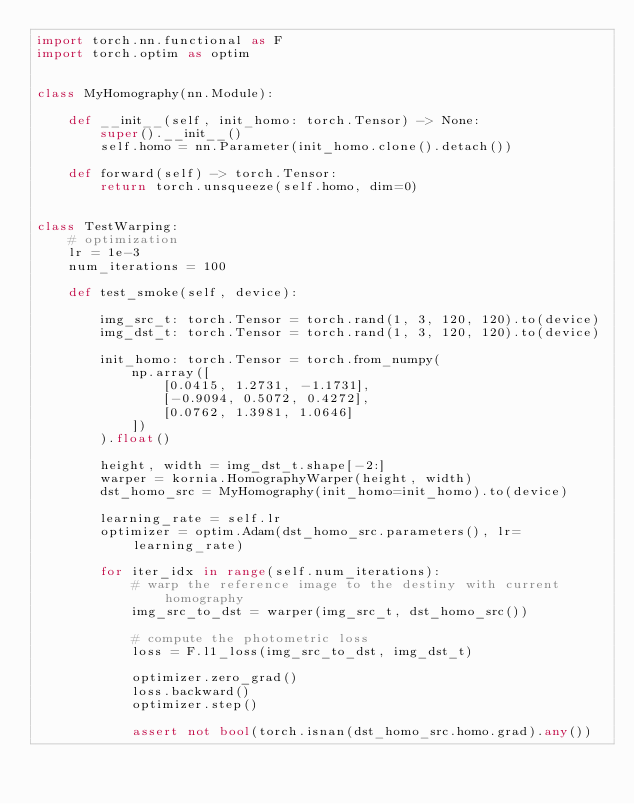Convert code to text. <code><loc_0><loc_0><loc_500><loc_500><_Python_>import torch.nn.functional as F
import torch.optim as optim


class MyHomography(nn.Module):

    def __init__(self, init_homo: torch.Tensor) -> None:
        super().__init__()
        self.homo = nn.Parameter(init_homo.clone().detach())

    def forward(self) -> torch.Tensor:
        return torch.unsqueeze(self.homo, dim=0)


class TestWarping:
    # optimization
    lr = 1e-3
    num_iterations = 100

    def test_smoke(self, device):

        img_src_t: torch.Tensor = torch.rand(1, 3, 120, 120).to(device)
        img_dst_t: torch.Tensor = torch.rand(1, 3, 120, 120).to(device)

        init_homo: torch.Tensor = torch.from_numpy(
            np.array([
                [0.0415, 1.2731, -1.1731],
                [-0.9094, 0.5072, 0.4272],
                [0.0762, 1.3981, 1.0646]
            ])
        ).float()

        height, width = img_dst_t.shape[-2:]
        warper = kornia.HomographyWarper(height, width)
        dst_homo_src = MyHomography(init_homo=init_homo).to(device)

        learning_rate = self.lr
        optimizer = optim.Adam(dst_homo_src.parameters(), lr=learning_rate)

        for iter_idx in range(self.num_iterations):
            # warp the reference image to the destiny with current homography
            img_src_to_dst = warper(img_src_t, dst_homo_src())

            # compute the photometric loss
            loss = F.l1_loss(img_src_to_dst, img_dst_t)

            optimizer.zero_grad()
            loss.backward()
            optimizer.step()

            assert not bool(torch.isnan(dst_homo_src.homo.grad).any())
</code> 